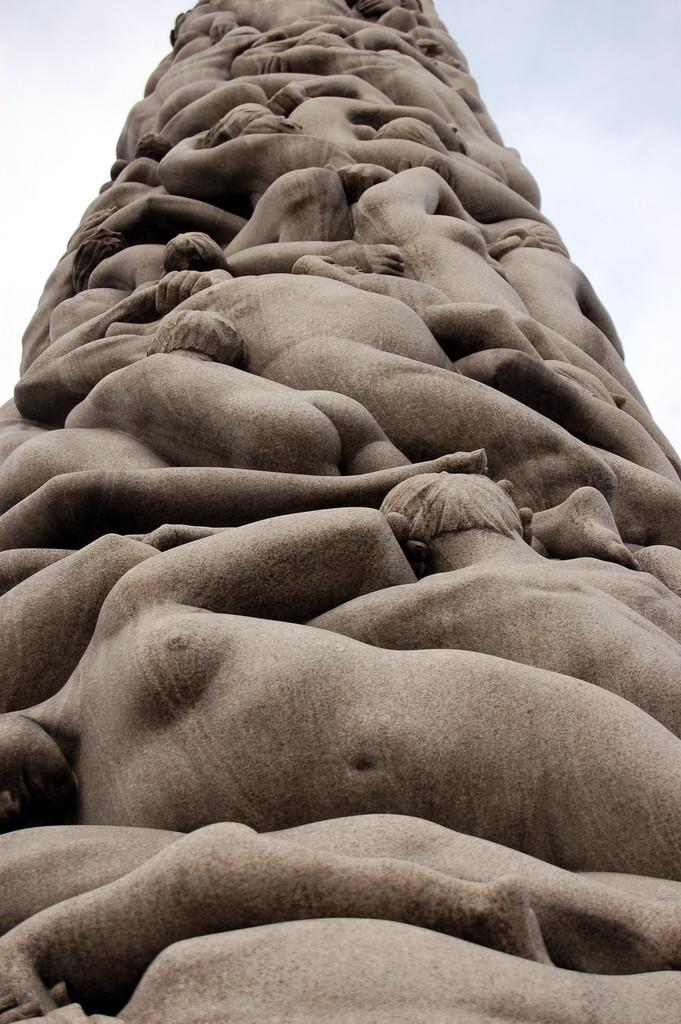How would you summarize this image in a sentence or two? In this image we can see the people sculpture. In the background we can see the sky. 